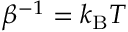Convert formula to latex. <formula><loc_0><loc_0><loc_500><loc_500>\beta ^ { - 1 } = k _ { B } T</formula> 